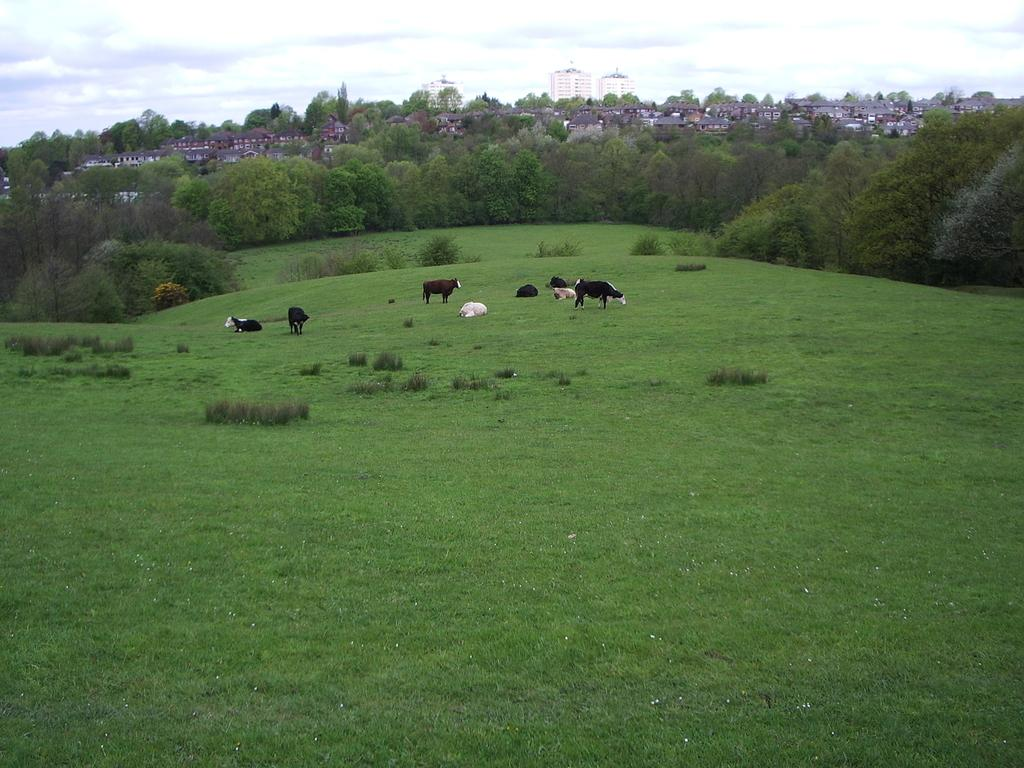What animals are in the center of the image? There are cows in the center of the image. What type of vegetation is at the bottom of the image? There is grass and plants at the bottom of the image. What structures can be seen in the background of the image? There are buildings in the background of the image. What type of vegetation is in the background of the image? There are trees in the background of the image. What is visible at the top of the image? The sky is visible at the top of the image. What type of copper object can be seen in the image? There is no copper object present in the image. How many stamps are visible on the cows in the image? There are no stamps visible on the cows in the image. 